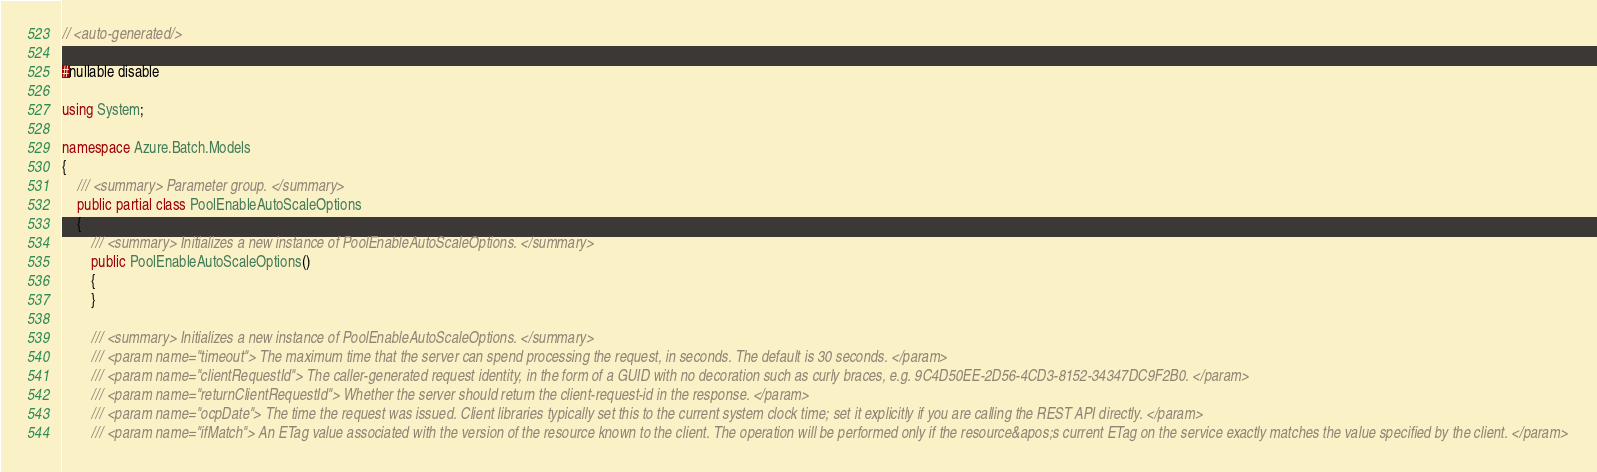Convert code to text. <code><loc_0><loc_0><loc_500><loc_500><_C#_>
// <auto-generated/>

#nullable disable

using System;

namespace Azure.Batch.Models
{
    /// <summary> Parameter group. </summary>
    public partial class PoolEnableAutoScaleOptions
    {
        /// <summary> Initializes a new instance of PoolEnableAutoScaleOptions. </summary>
        public PoolEnableAutoScaleOptions()
        {
        }

        /// <summary> Initializes a new instance of PoolEnableAutoScaleOptions. </summary>
        /// <param name="timeout"> The maximum time that the server can spend processing the request, in seconds. The default is 30 seconds. </param>
        /// <param name="clientRequestId"> The caller-generated request identity, in the form of a GUID with no decoration such as curly braces, e.g. 9C4D50EE-2D56-4CD3-8152-34347DC9F2B0. </param>
        /// <param name="returnClientRequestId"> Whether the server should return the client-request-id in the response. </param>
        /// <param name="ocpDate"> The time the request was issued. Client libraries typically set this to the current system clock time; set it explicitly if you are calling the REST API directly. </param>
        /// <param name="ifMatch"> An ETag value associated with the version of the resource known to the client. The operation will be performed only if the resource&apos;s current ETag on the service exactly matches the value specified by the client. </param></code> 